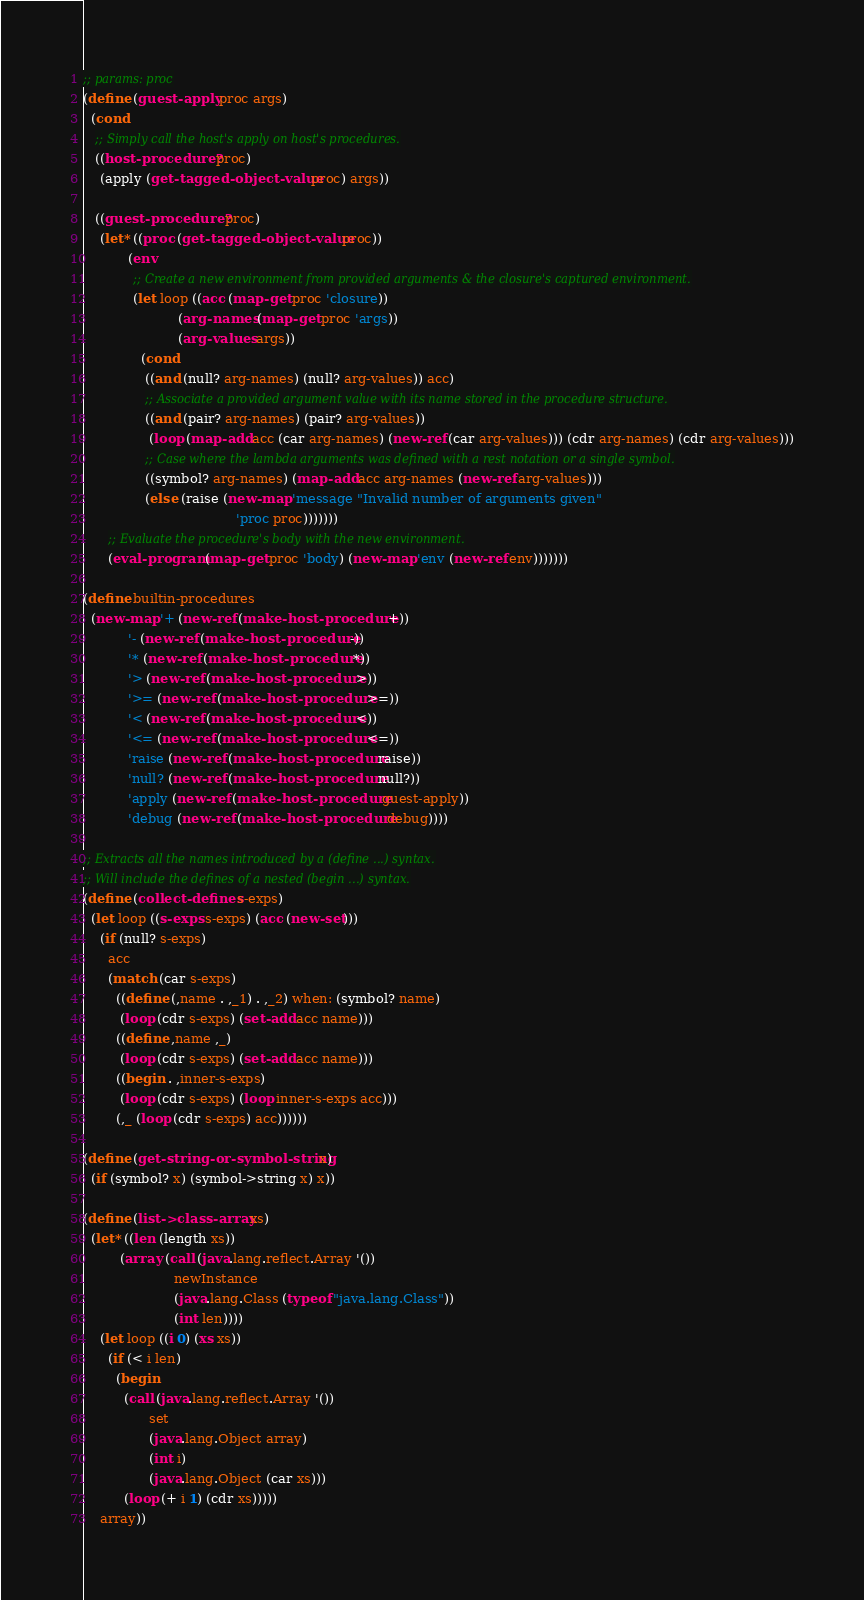<code> <loc_0><loc_0><loc_500><loc_500><_Scheme_>;; params: proc
(define (guest-apply proc args)
  (cond
   ;; Simply call the host's apply on host's procedures.
   ((host-procedure? proc)
    (apply (get-tagged-object-value proc) args))

   ((guest-procedure? proc)
    (let* ((proc (get-tagged-object-value proc))
           (env
            ;; Create a new environment from provided arguments & the closure's captured environment.
            (let loop ((acc (map-get proc 'closure))
                       (arg-names (map-get proc 'args))
                       (arg-values args))
              (cond
               ((and (null? arg-names) (null? arg-values)) acc)
               ;; Associate a provided argument value with its name stored in the procedure structure.
               ((and (pair? arg-names) (pair? arg-values))
                (loop (map-add acc (car arg-names) (new-ref (car arg-values))) (cdr arg-names) (cdr arg-values)))
               ;; Case where the lambda arguments was defined with a rest notation or a single symbol.
               ((symbol? arg-names) (map-add acc arg-names (new-ref arg-values)))
               (else (raise (new-map 'message "Invalid number of arguments given"
                                     'proc proc)))))))
      ;; Evaluate the procedure's body with the new environment.
      (eval-program (map-get proc 'body) (new-map 'env (new-ref env)))))))

(define builtin-procedures
  (new-map '+ (new-ref (make-host-procedure +))
           '- (new-ref (make-host-procedure -))
           '* (new-ref (make-host-procedure *))
           '> (new-ref (make-host-procedure >))
           '>= (new-ref (make-host-procedure >=))
           '< (new-ref (make-host-procedure <))
           '<= (new-ref (make-host-procedure <=))
           'raise (new-ref (make-host-procedure raise))
           'null? (new-ref (make-host-procedure null?))
           'apply (new-ref (make-host-procedure guest-apply))
           'debug (new-ref (make-host-procedure debug))))

;; Extracts all the names introduced by a (define ...) syntax.
;; Will include the defines of a nested (begin ...) syntax.
(define (collect-defines s-exps)
  (let loop ((s-exps s-exps) (acc (new-set)))
    (if (null? s-exps)
      acc
      (match (car s-exps)
        ((define (,name . ,_1) . ,_2) when: (symbol? name)
         (loop (cdr s-exps) (set-add acc name)))
        ((define ,name ,_)
         (loop (cdr s-exps) (set-add acc name)))
        ((begin . ,inner-s-exps)
         (loop (cdr s-exps) (loop inner-s-exps acc)))
        (,_ (loop (cdr s-exps) acc))))))

(define (get-string-or-symbol-string x)
  (if (symbol? x) (symbol->string x) x))

(define (list->class-array xs)
  (let* ((len (length xs))
         (array (call (java.lang.reflect.Array '())
                      newInstance
                      (java.lang.Class (typeof "java.lang.Class"))
                      (int len))))
    (let loop ((i 0) (xs xs))
      (if (< i len)
        (begin
          (call (java.lang.reflect.Array '())
                set
                (java.lang.Object array)
                (int i)
                (java.lang.Object (car xs)))
          (loop (+ i 1) (cdr xs)))))
    array))
</code> 